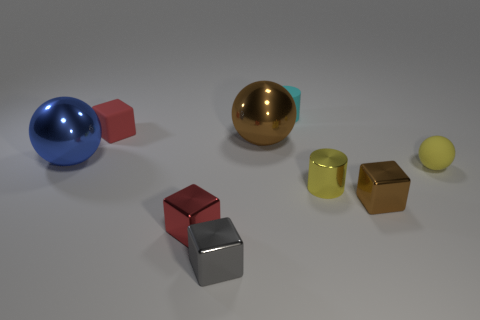Subtract all red shiny blocks. How many blocks are left? 3 Subtract 2 cylinders. How many cylinders are left? 0 Add 1 gray objects. How many objects exist? 10 Subtract all brown cylinders. How many red cubes are left? 2 Subtract all red blocks. How many blocks are left? 2 Subtract all cylinders. How many objects are left? 7 Add 9 small yellow matte spheres. How many small yellow matte spheres are left? 10 Add 2 gray metal objects. How many gray metal objects exist? 3 Subtract 1 red cubes. How many objects are left? 8 Subtract all purple cylinders. Subtract all yellow balls. How many cylinders are left? 2 